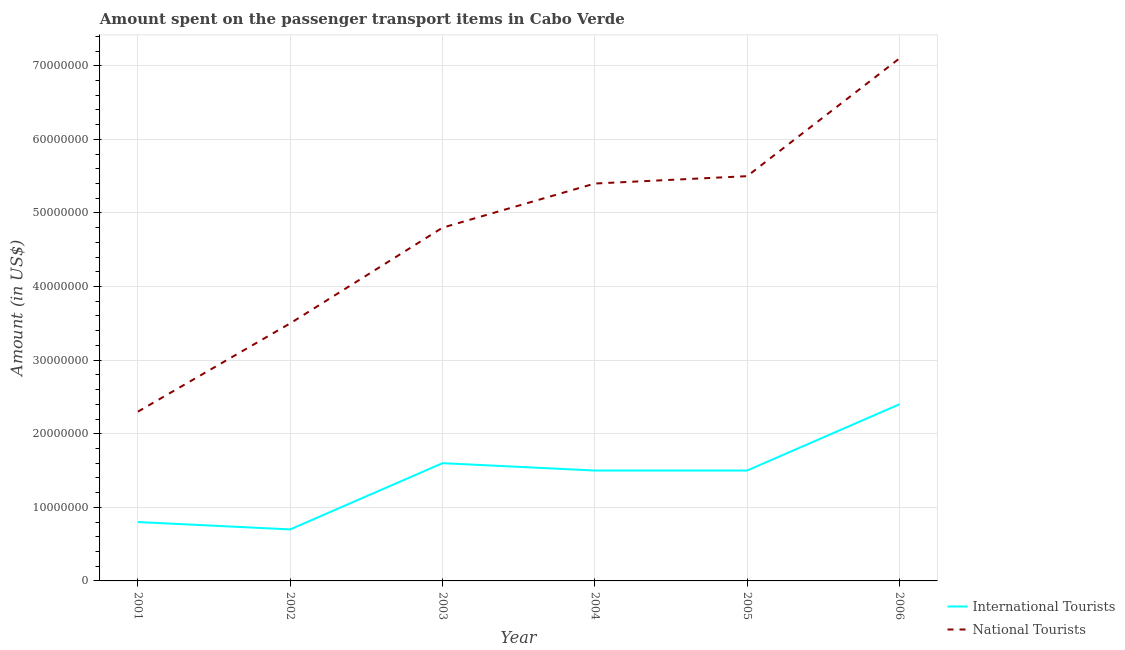Is the number of lines equal to the number of legend labels?
Provide a short and direct response. Yes. What is the amount spent on transport items of national tourists in 2002?
Keep it short and to the point. 3.50e+07. Across all years, what is the maximum amount spent on transport items of international tourists?
Ensure brevity in your answer.  2.40e+07. Across all years, what is the minimum amount spent on transport items of international tourists?
Provide a short and direct response. 7.00e+06. In which year was the amount spent on transport items of international tourists maximum?
Your answer should be very brief. 2006. What is the total amount spent on transport items of national tourists in the graph?
Make the answer very short. 2.86e+08. What is the difference between the amount spent on transport items of international tourists in 2002 and that in 2005?
Provide a succinct answer. -8.00e+06. What is the difference between the amount spent on transport items of international tourists in 2004 and the amount spent on transport items of national tourists in 2001?
Your answer should be very brief. -8.00e+06. What is the average amount spent on transport items of international tourists per year?
Give a very brief answer. 1.42e+07. In the year 2006, what is the difference between the amount spent on transport items of international tourists and amount spent on transport items of national tourists?
Offer a terse response. -4.70e+07. In how many years, is the amount spent on transport items of international tourists greater than 8000000 US$?
Provide a succinct answer. 4. What is the ratio of the amount spent on transport items of national tourists in 2001 to that in 2006?
Your answer should be very brief. 0.32. What is the difference between the highest and the second highest amount spent on transport items of national tourists?
Make the answer very short. 1.60e+07. What is the difference between the highest and the lowest amount spent on transport items of international tourists?
Provide a succinct answer. 1.70e+07. In how many years, is the amount spent on transport items of international tourists greater than the average amount spent on transport items of international tourists taken over all years?
Make the answer very short. 4. Does the amount spent on transport items of international tourists monotonically increase over the years?
Provide a succinct answer. No. Is the amount spent on transport items of national tourists strictly less than the amount spent on transport items of international tourists over the years?
Offer a terse response. No. How many lines are there?
Your answer should be compact. 2. How many years are there in the graph?
Your answer should be very brief. 6. What is the difference between two consecutive major ticks on the Y-axis?
Provide a succinct answer. 1.00e+07. Does the graph contain any zero values?
Offer a terse response. No. Does the graph contain grids?
Provide a short and direct response. Yes. Where does the legend appear in the graph?
Offer a very short reply. Bottom right. How many legend labels are there?
Provide a succinct answer. 2. What is the title of the graph?
Make the answer very short. Amount spent on the passenger transport items in Cabo Verde. What is the label or title of the X-axis?
Give a very brief answer. Year. What is the Amount (in US$) in International Tourists in 2001?
Ensure brevity in your answer.  8.00e+06. What is the Amount (in US$) in National Tourists in 2001?
Give a very brief answer. 2.30e+07. What is the Amount (in US$) in International Tourists in 2002?
Your response must be concise. 7.00e+06. What is the Amount (in US$) in National Tourists in 2002?
Ensure brevity in your answer.  3.50e+07. What is the Amount (in US$) in International Tourists in 2003?
Ensure brevity in your answer.  1.60e+07. What is the Amount (in US$) in National Tourists in 2003?
Keep it short and to the point. 4.80e+07. What is the Amount (in US$) of International Tourists in 2004?
Provide a succinct answer. 1.50e+07. What is the Amount (in US$) in National Tourists in 2004?
Provide a short and direct response. 5.40e+07. What is the Amount (in US$) in International Tourists in 2005?
Ensure brevity in your answer.  1.50e+07. What is the Amount (in US$) in National Tourists in 2005?
Ensure brevity in your answer.  5.50e+07. What is the Amount (in US$) of International Tourists in 2006?
Offer a terse response. 2.40e+07. What is the Amount (in US$) in National Tourists in 2006?
Your answer should be compact. 7.10e+07. Across all years, what is the maximum Amount (in US$) of International Tourists?
Your response must be concise. 2.40e+07. Across all years, what is the maximum Amount (in US$) in National Tourists?
Ensure brevity in your answer.  7.10e+07. Across all years, what is the minimum Amount (in US$) in International Tourists?
Provide a succinct answer. 7.00e+06. Across all years, what is the minimum Amount (in US$) in National Tourists?
Your answer should be very brief. 2.30e+07. What is the total Amount (in US$) of International Tourists in the graph?
Ensure brevity in your answer.  8.50e+07. What is the total Amount (in US$) in National Tourists in the graph?
Your response must be concise. 2.86e+08. What is the difference between the Amount (in US$) of International Tourists in 2001 and that in 2002?
Keep it short and to the point. 1.00e+06. What is the difference between the Amount (in US$) in National Tourists in 2001 and that in 2002?
Make the answer very short. -1.20e+07. What is the difference between the Amount (in US$) in International Tourists in 2001 and that in 2003?
Provide a succinct answer. -8.00e+06. What is the difference between the Amount (in US$) in National Tourists in 2001 and that in 2003?
Make the answer very short. -2.50e+07. What is the difference between the Amount (in US$) of International Tourists in 2001 and that in 2004?
Provide a short and direct response. -7.00e+06. What is the difference between the Amount (in US$) in National Tourists in 2001 and that in 2004?
Your answer should be very brief. -3.10e+07. What is the difference between the Amount (in US$) of International Tourists in 2001 and that in 2005?
Offer a very short reply. -7.00e+06. What is the difference between the Amount (in US$) of National Tourists in 2001 and that in 2005?
Keep it short and to the point. -3.20e+07. What is the difference between the Amount (in US$) of International Tourists in 2001 and that in 2006?
Your answer should be compact. -1.60e+07. What is the difference between the Amount (in US$) in National Tourists in 2001 and that in 2006?
Give a very brief answer. -4.80e+07. What is the difference between the Amount (in US$) of International Tourists in 2002 and that in 2003?
Provide a succinct answer. -9.00e+06. What is the difference between the Amount (in US$) in National Tourists in 2002 and that in 2003?
Your answer should be compact. -1.30e+07. What is the difference between the Amount (in US$) of International Tourists in 2002 and that in 2004?
Give a very brief answer. -8.00e+06. What is the difference between the Amount (in US$) in National Tourists in 2002 and that in 2004?
Your answer should be compact. -1.90e+07. What is the difference between the Amount (in US$) of International Tourists in 2002 and that in 2005?
Give a very brief answer. -8.00e+06. What is the difference between the Amount (in US$) in National Tourists in 2002 and that in 2005?
Provide a succinct answer. -2.00e+07. What is the difference between the Amount (in US$) of International Tourists in 2002 and that in 2006?
Provide a succinct answer. -1.70e+07. What is the difference between the Amount (in US$) of National Tourists in 2002 and that in 2006?
Your response must be concise. -3.60e+07. What is the difference between the Amount (in US$) of National Tourists in 2003 and that in 2004?
Your answer should be very brief. -6.00e+06. What is the difference between the Amount (in US$) of National Tourists in 2003 and that in 2005?
Make the answer very short. -7.00e+06. What is the difference between the Amount (in US$) in International Tourists in 2003 and that in 2006?
Make the answer very short. -8.00e+06. What is the difference between the Amount (in US$) of National Tourists in 2003 and that in 2006?
Your answer should be compact. -2.30e+07. What is the difference between the Amount (in US$) of International Tourists in 2004 and that in 2005?
Give a very brief answer. 0. What is the difference between the Amount (in US$) of National Tourists in 2004 and that in 2005?
Offer a terse response. -1.00e+06. What is the difference between the Amount (in US$) of International Tourists in 2004 and that in 2006?
Ensure brevity in your answer.  -9.00e+06. What is the difference between the Amount (in US$) of National Tourists in 2004 and that in 2006?
Offer a very short reply. -1.70e+07. What is the difference between the Amount (in US$) in International Tourists in 2005 and that in 2006?
Keep it short and to the point. -9.00e+06. What is the difference between the Amount (in US$) in National Tourists in 2005 and that in 2006?
Your answer should be very brief. -1.60e+07. What is the difference between the Amount (in US$) in International Tourists in 2001 and the Amount (in US$) in National Tourists in 2002?
Your answer should be compact. -2.70e+07. What is the difference between the Amount (in US$) of International Tourists in 2001 and the Amount (in US$) of National Tourists in 2003?
Provide a succinct answer. -4.00e+07. What is the difference between the Amount (in US$) of International Tourists in 2001 and the Amount (in US$) of National Tourists in 2004?
Make the answer very short. -4.60e+07. What is the difference between the Amount (in US$) of International Tourists in 2001 and the Amount (in US$) of National Tourists in 2005?
Make the answer very short. -4.70e+07. What is the difference between the Amount (in US$) in International Tourists in 2001 and the Amount (in US$) in National Tourists in 2006?
Make the answer very short. -6.30e+07. What is the difference between the Amount (in US$) of International Tourists in 2002 and the Amount (in US$) of National Tourists in 2003?
Provide a short and direct response. -4.10e+07. What is the difference between the Amount (in US$) of International Tourists in 2002 and the Amount (in US$) of National Tourists in 2004?
Offer a very short reply. -4.70e+07. What is the difference between the Amount (in US$) in International Tourists in 2002 and the Amount (in US$) in National Tourists in 2005?
Keep it short and to the point. -4.80e+07. What is the difference between the Amount (in US$) in International Tourists in 2002 and the Amount (in US$) in National Tourists in 2006?
Provide a succinct answer. -6.40e+07. What is the difference between the Amount (in US$) of International Tourists in 2003 and the Amount (in US$) of National Tourists in 2004?
Keep it short and to the point. -3.80e+07. What is the difference between the Amount (in US$) in International Tourists in 2003 and the Amount (in US$) in National Tourists in 2005?
Provide a short and direct response. -3.90e+07. What is the difference between the Amount (in US$) of International Tourists in 2003 and the Amount (in US$) of National Tourists in 2006?
Keep it short and to the point. -5.50e+07. What is the difference between the Amount (in US$) in International Tourists in 2004 and the Amount (in US$) in National Tourists in 2005?
Provide a succinct answer. -4.00e+07. What is the difference between the Amount (in US$) in International Tourists in 2004 and the Amount (in US$) in National Tourists in 2006?
Give a very brief answer. -5.60e+07. What is the difference between the Amount (in US$) of International Tourists in 2005 and the Amount (in US$) of National Tourists in 2006?
Offer a very short reply. -5.60e+07. What is the average Amount (in US$) of International Tourists per year?
Give a very brief answer. 1.42e+07. What is the average Amount (in US$) in National Tourists per year?
Your answer should be very brief. 4.77e+07. In the year 2001, what is the difference between the Amount (in US$) in International Tourists and Amount (in US$) in National Tourists?
Your response must be concise. -1.50e+07. In the year 2002, what is the difference between the Amount (in US$) of International Tourists and Amount (in US$) of National Tourists?
Provide a succinct answer. -2.80e+07. In the year 2003, what is the difference between the Amount (in US$) of International Tourists and Amount (in US$) of National Tourists?
Provide a short and direct response. -3.20e+07. In the year 2004, what is the difference between the Amount (in US$) of International Tourists and Amount (in US$) of National Tourists?
Offer a terse response. -3.90e+07. In the year 2005, what is the difference between the Amount (in US$) of International Tourists and Amount (in US$) of National Tourists?
Keep it short and to the point. -4.00e+07. In the year 2006, what is the difference between the Amount (in US$) of International Tourists and Amount (in US$) of National Tourists?
Offer a very short reply. -4.70e+07. What is the ratio of the Amount (in US$) of National Tourists in 2001 to that in 2002?
Ensure brevity in your answer.  0.66. What is the ratio of the Amount (in US$) in International Tourists in 2001 to that in 2003?
Ensure brevity in your answer.  0.5. What is the ratio of the Amount (in US$) in National Tourists in 2001 to that in 2003?
Offer a terse response. 0.48. What is the ratio of the Amount (in US$) in International Tourists in 2001 to that in 2004?
Your answer should be very brief. 0.53. What is the ratio of the Amount (in US$) in National Tourists in 2001 to that in 2004?
Your response must be concise. 0.43. What is the ratio of the Amount (in US$) in International Tourists in 2001 to that in 2005?
Offer a terse response. 0.53. What is the ratio of the Amount (in US$) in National Tourists in 2001 to that in 2005?
Provide a short and direct response. 0.42. What is the ratio of the Amount (in US$) in International Tourists in 2001 to that in 2006?
Your answer should be compact. 0.33. What is the ratio of the Amount (in US$) in National Tourists in 2001 to that in 2006?
Your answer should be compact. 0.32. What is the ratio of the Amount (in US$) in International Tourists in 2002 to that in 2003?
Make the answer very short. 0.44. What is the ratio of the Amount (in US$) of National Tourists in 2002 to that in 2003?
Your answer should be compact. 0.73. What is the ratio of the Amount (in US$) of International Tourists in 2002 to that in 2004?
Keep it short and to the point. 0.47. What is the ratio of the Amount (in US$) of National Tourists in 2002 to that in 2004?
Provide a succinct answer. 0.65. What is the ratio of the Amount (in US$) of International Tourists in 2002 to that in 2005?
Provide a short and direct response. 0.47. What is the ratio of the Amount (in US$) of National Tourists in 2002 to that in 2005?
Your answer should be very brief. 0.64. What is the ratio of the Amount (in US$) of International Tourists in 2002 to that in 2006?
Your response must be concise. 0.29. What is the ratio of the Amount (in US$) in National Tourists in 2002 to that in 2006?
Keep it short and to the point. 0.49. What is the ratio of the Amount (in US$) in International Tourists in 2003 to that in 2004?
Provide a short and direct response. 1.07. What is the ratio of the Amount (in US$) of International Tourists in 2003 to that in 2005?
Provide a succinct answer. 1.07. What is the ratio of the Amount (in US$) of National Tourists in 2003 to that in 2005?
Make the answer very short. 0.87. What is the ratio of the Amount (in US$) in National Tourists in 2003 to that in 2006?
Your response must be concise. 0.68. What is the ratio of the Amount (in US$) in International Tourists in 2004 to that in 2005?
Ensure brevity in your answer.  1. What is the ratio of the Amount (in US$) of National Tourists in 2004 to that in 2005?
Make the answer very short. 0.98. What is the ratio of the Amount (in US$) in National Tourists in 2004 to that in 2006?
Give a very brief answer. 0.76. What is the ratio of the Amount (in US$) in National Tourists in 2005 to that in 2006?
Your answer should be compact. 0.77. What is the difference between the highest and the second highest Amount (in US$) of National Tourists?
Give a very brief answer. 1.60e+07. What is the difference between the highest and the lowest Amount (in US$) of International Tourists?
Provide a short and direct response. 1.70e+07. What is the difference between the highest and the lowest Amount (in US$) in National Tourists?
Offer a terse response. 4.80e+07. 